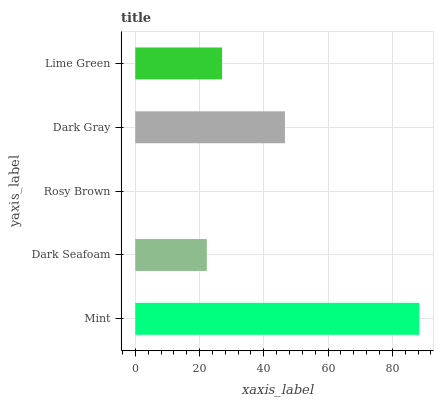Is Rosy Brown the minimum?
Answer yes or no. Yes. Is Mint the maximum?
Answer yes or no. Yes. Is Dark Seafoam the minimum?
Answer yes or no. No. Is Dark Seafoam the maximum?
Answer yes or no. No. Is Mint greater than Dark Seafoam?
Answer yes or no. Yes. Is Dark Seafoam less than Mint?
Answer yes or no. Yes. Is Dark Seafoam greater than Mint?
Answer yes or no. No. Is Mint less than Dark Seafoam?
Answer yes or no. No. Is Lime Green the high median?
Answer yes or no. Yes. Is Lime Green the low median?
Answer yes or no. Yes. Is Rosy Brown the high median?
Answer yes or no. No. Is Rosy Brown the low median?
Answer yes or no. No. 